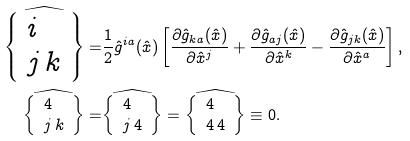<formula> <loc_0><loc_0><loc_500><loc_500>\widehat { \left \{ \begin{array} { l } i \\ j \, k \end{array} \right \} } = & \frac { 1 } { 2 } \hat { g } ^ { i a } ( \hat { x } ) \left [ \frac { \partial \hat { g } _ { k a } ( \hat { x } ) } { \partial \hat { x } ^ { j } } + \frac { \partial \hat { g } _ { a j } ( \hat { x } ) } { \partial \hat { x } ^ { k } } - \frac { \partial \hat { g } _ { j k } ( \hat { x } ) } { \partial \hat { x } ^ { a } } \right ] , \\ \widehat { \left \{ \begin{array} { l } 4 \\ j \, k \end{array} \right \} } = & \widehat { \left \{ \begin{array} { l } 4 \\ j \, 4 \end{array} \right \} } = \widehat { \left \{ \begin{array} { l } 4 \\ 4 \, 4 \end{array} \right \} } \equiv 0 .</formula> 